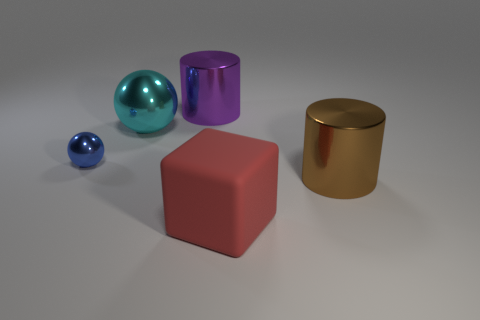Add 2 large cylinders. How many objects exist? 7 Subtract all brown cylinders. How many cylinders are left? 1 Subtract all cylinders. How many objects are left? 3 Subtract 1 blocks. How many blocks are left? 0 Subtract all green blocks. How many brown cylinders are left? 1 Subtract all tiny blue cubes. Subtract all purple objects. How many objects are left? 4 Add 1 big cyan shiny balls. How many big cyan shiny balls are left? 2 Add 5 large metallic balls. How many large metallic balls exist? 6 Subtract 0 brown spheres. How many objects are left? 5 Subtract all blue balls. Subtract all cyan cylinders. How many balls are left? 1 